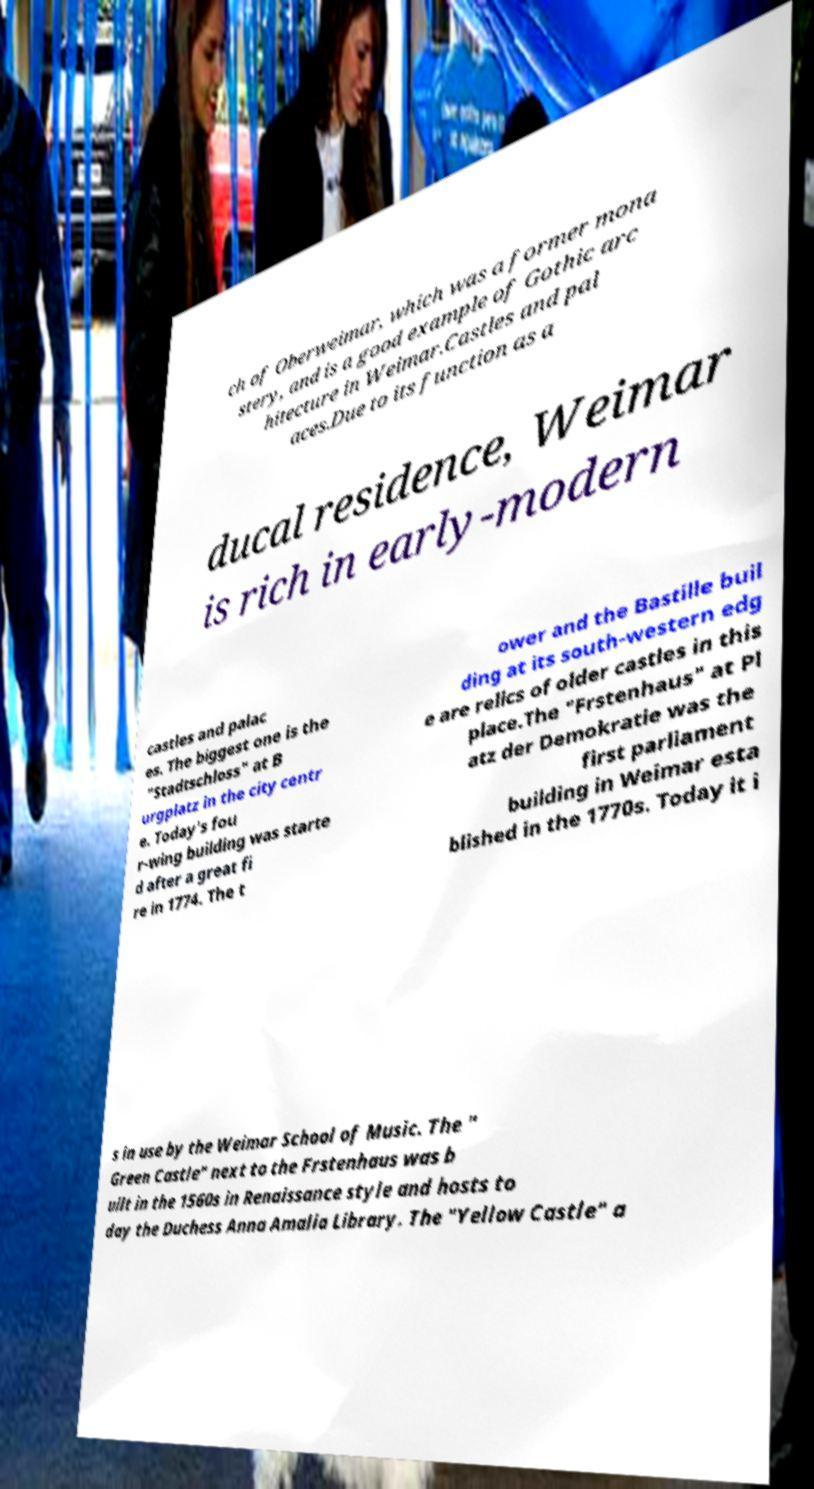What messages or text are displayed in this image? I need them in a readable, typed format. ch of Oberweimar, which was a former mona stery, and is a good example of Gothic arc hitecture in Weimar.Castles and pal aces.Due to its function as a ducal residence, Weimar is rich in early-modern castles and palac es. The biggest one is the "Stadtschloss" at B urgplatz in the city centr e. Today's fou r-wing building was starte d after a great fi re in 1774. The t ower and the Bastille buil ding at its south-western edg e are relics of older castles in this place.The "Frstenhaus" at Pl atz der Demokratie was the first parliament building in Weimar esta blished in the 1770s. Today it i s in use by the Weimar School of Music. The " Green Castle" next to the Frstenhaus was b uilt in the 1560s in Renaissance style and hosts to day the Duchess Anna Amalia Library. The "Yellow Castle" a 